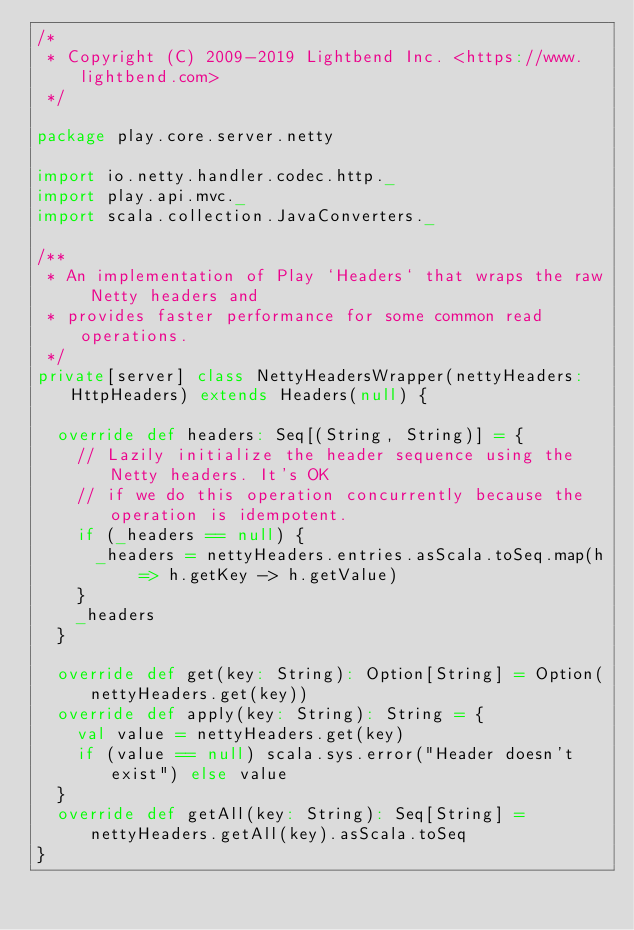Convert code to text. <code><loc_0><loc_0><loc_500><loc_500><_Scala_>/*
 * Copyright (C) 2009-2019 Lightbend Inc. <https://www.lightbend.com>
 */

package play.core.server.netty

import io.netty.handler.codec.http._
import play.api.mvc._
import scala.collection.JavaConverters._

/**
 * An implementation of Play `Headers` that wraps the raw Netty headers and
 * provides faster performance for some common read operations.
 */
private[server] class NettyHeadersWrapper(nettyHeaders: HttpHeaders) extends Headers(null) {

  override def headers: Seq[(String, String)] = {
    // Lazily initialize the header sequence using the Netty headers. It's OK
    // if we do this operation concurrently because the operation is idempotent.
    if (_headers == null) {
      _headers = nettyHeaders.entries.asScala.toSeq.map(h => h.getKey -> h.getValue)
    }
    _headers
  }

  override def get(key: String): Option[String] = Option(nettyHeaders.get(key))
  override def apply(key: String): String = {
    val value = nettyHeaders.get(key)
    if (value == null) scala.sys.error("Header doesn't exist") else value
  }
  override def getAll(key: String): Seq[String] = nettyHeaders.getAll(key).asScala.toSeq
}
</code> 